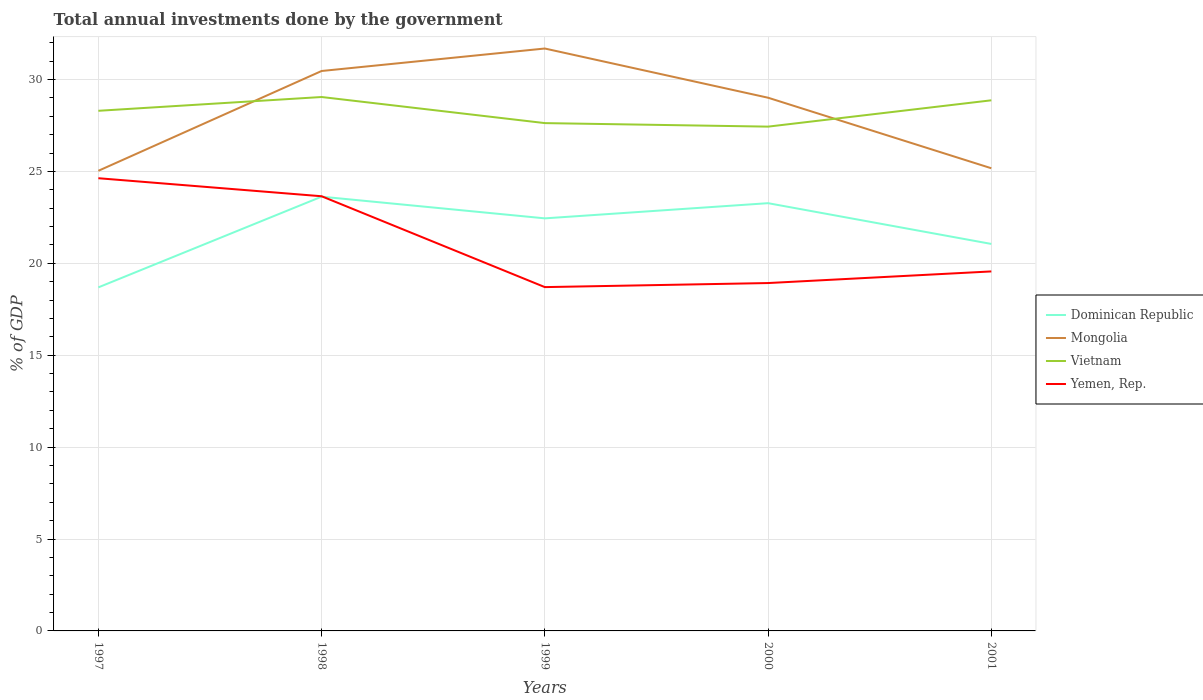Is the number of lines equal to the number of legend labels?
Provide a short and direct response. Yes. Across all years, what is the maximum total annual investments done by the government in Dominican Republic?
Your answer should be compact. 18.69. In which year was the total annual investments done by the government in Mongolia maximum?
Make the answer very short. 1997. What is the total total annual investments done by the government in Dominican Republic in the graph?
Your response must be concise. 1.18. What is the difference between the highest and the second highest total annual investments done by the government in Mongolia?
Your answer should be very brief. 6.65. What is the difference between the highest and the lowest total annual investments done by the government in Yemen, Rep.?
Provide a short and direct response. 2. Is the total annual investments done by the government in Yemen, Rep. strictly greater than the total annual investments done by the government in Dominican Republic over the years?
Offer a very short reply. No. How many years are there in the graph?
Keep it short and to the point. 5. What is the difference between two consecutive major ticks on the Y-axis?
Offer a terse response. 5. Does the graph contain any zero values?
Your answer should be compact. No. How are the legend labels stacked?
Keep it short and to the point. Vertical. What is the title of the graph?
Provide a short and direct response. Total annual investments done by the government. Does "Senegal" appear as one of the legend labels in the graph?
Offer a terse response. No. What is the label or title of the X-axis?
Provide a short and direct response. Years. What is the label or title of the Y-axis?
Provide a succinct answer. % of GDP. What is the % of GDP of Dominican Republic in 1997?
Your response must be concise. 18.69. What is the % of GDP in Mongolia in 1997?
Provide a succinct answer. 25.03. What is the % of GDP of Vietnam in 1997?
Your response must be concise. 28.3. What is the % of GDP of Yemen, Rep. in 1997?
Offer a terse response. 24.63. What is the % of GDP of Dominican Republic in 1998?
Keep it short and to the point. 23.63. What is the % of GDP of Mongolia in 1998?
Keep it short and to the point. 30.47. What is the % of GDP of Vietnam in 1998?
Provide a succinct answer. 29.05. What is the % of GDP in Yemen, Rep. in 1998?
Your answer should be very brief. 23.65. What is the % of GDP of Dominican Republic in 1999?
Make the answer very short. 22.45. What is the % of GDP of Mongolia in 1999?
Make the answer very short. 31.69. What is the % of GDP in Vietnam in 1999?
Ensure brevity in your answer.  27.63. What is the % of GDP of Yemen, Rep. in 1999?
Give a very brief answer. 18.71. What is the % of GDP of Dominican Republic in 2000?
Offer a terse response. 23.27. What is the % of GDP of Mongolia in 2000?
Offer a terse response. 29.01. What is the % of GDP in Vietnam in 2000?
Your response must be concise. 27.44. What is the % of GDP of Yemen, Rep. in 2000?
Keep it short and to the point. 18.93. What is the % of GDP in Dominican Republic in 2001?
Keep it short and to the point. 21.06. What is the % of GDP in Mongolia in 2001?
Provide a succinct answer. 25.17. What is the % of GDP of Vietnam in 2001?
Your response must be concise. 28.87. What is the % of GDP of Yemen, Rep. in 2001?
Keep it short and to the point. 19.56. Across all years, what is the maximum % of GDP of Dominican Republic?
Keep it short and to the point. 23.63. Across all years, what is the maximum % of GDP in Mongolia?
Ensure brevity in your answer.  31.69. Across all years, what is the maximum % of GDP of Vietnam?
Provide a succinct answer. 29.05. Across all years, what is the maximum % of GDP of Yemen, Rep.?
Keep it short and to the point. 24.63. Across all years, what is the minimum % of GDP in Dominican Republic?
Make the answer very short. 18.69. Across all years, what is the minimum % of GDP of Mongolia?
Offer a very short reply. 25.03. Across all years, what is the minimum % of GDP of Vietnam?
Make the answer very short. 27.44. Across all years, what is the minimum % of GDP in Yemen, Rep.?
Provide a short and direct response. 18.71. What is the total % of GDP of Dominican Republic in the graph?
Ensure brevity in your answer.  109.1. What is the total % of GDP of Mongolia in the graph?
Keep it short and to the point. 141.37. What is the total % of GDP of Vietnam in the graph?
Give a very brief answer. 141.29. What is the total % of GDP in Yemen, Rep. in the graph?
Provide a short and direct response. 105.48. What is the difference between the % of GDP in Dominican Republic in 1997 and that in 1998?
Your answer should be compact. -4.93. What is the difference between the % of GDP of Mongolia in 1997 and that in 1998?
Provide a succinct answer. -5.43. What is the difference between the % of GDP in Vietnam in 1997 and that in 1998?
Your response must be concise. -0.75. What is the difference between the % of GDP in Yemen, Rep. in 1997 and that in 1998?
Your answer should be compact. 0.98. What is the difference between the % of GDP of Dominican Republic in 1997 and that in 1999?
Offer a very short reply. -3.76. What is the difference between the % of GDP in Mongolia in 1997 and that in 1999?
Provide a short and direct response. -6.65. What is the difference between the % of GDP of Vietnam in 1997 and that in 1999?
Give a very brief answer. 0.67. What is the difference between the % of GDP of Yemen, Rep. in 1997 and that in 1999?
Offer a terse response. 5.92. What is the difference between the % of GDP of Dominican Republic in 1997 and that in 2000?
Keep it short and to the point. -4.58. What is the difference between the % of GDP in Mongolia in 1997 and that in 2000?
Offer a very short reply. -3.98. What is the difference between the % of GDP of Vietnam in 1997 and that in 2000?
Provide a succinct answer. 0.86. What is the difference between the % of GDP in Yemen, Rep. in 1997 and that in 2000?
Give a very brief answer. 5.7. What is the difference between the % of GDP of Dominican Republic in 1997 and that in 2001?
Your answer should be very brief. -2.36. What is the difference between the % of GDP in Mongolia in 1997 and that in 2001?
Offer a terse response. -0.14. What is the difference between the % of GDP of Vietnam in 1997 and that in 2001?
Give a very brief answer. -0.57. What is the difference between the % of GDP of Yemen, Rep. in 1997 and that in 2001?
Provide a short and direct response. 5.07. What is the difference between the % of GDP of Dominican Republic in 1998 and that in 1999?
Your answer should be compact. 1.18. What is the difference between the % of GDP of Mongolia in 1998 and that in 1999?
Offer a very short reply. -1.22. What is the difference between the % of GDP of Vietnam in 1998 and that in 1999?
Your answer should be very brief. 1.42. What is the difference between the % of GDP of Yemen, Rep. in 1998 and that in 1999?
Your answer should be very brief. 4.94. What is the difference between the % of GDP of Dominican Republic in 1998 and that in 2000?
Ensure brevity in your answer.  0.35. What is the difference between the % of GDP of Mongolia in 1998 and that in 2000?
Offer a terse response. 1.45. What is the difference between the % of GDP of Vietnam in 1998 and that in 2000?
Provide a short and direct response. 1.61. What is the difference between the % of GDP in Yemen, Rep. in 1998 and that in 2000?
Provide a short and direct response. 4.72. What is the difference between the % of GDP in Dominican Republic in 1998 and that in 2001?
Offer a terse response. 2.57. What is the difference between the % of GDP in Mongolia in 1998 and that in 2001?
Make the answer very short. 5.29. What is the difference between the % of GDP in Vietnam in 1998 and that in 2001?
Your answer should be compact. 0.18. What is the difference between the % of GDP in Yemen, Rep. in 1998 and that in 2001?
Provide a short and direct response. 4.09. What is the difference between the % of GDP in Dominican Republic in 1999 and that in 2000?
Offer a very short reply. -0.83. What is the difference between the % of GDP of Mongolia in 1999 and that in 2000?
Keep it short and to the point. 2.68. What is the difference between the % of GDP in Vietnam in 1999 and that in 2000?
Keep it short and to the point. 0.19. What is the difference between the % of GDP of Yemen, Rep. in 1999 and that in 2000?
Ensure brevity in your answer.  -0.22. What is the difference between the % of GDP in Dominican Republic in 1999 and that in 2001?
Give a very brief answer. 1.39. What is the difference between the % of GDP in Mongolia in 1999 and that in 2001?
Your answer should be compact. 6.51. What is the difference between the % of GDP in Vietnam in 1999 and that in 2001?
Offer a terse response. -1.24. What is the difference between the % of GDP in Yemen, Rep. in 1999 and that in 2001?
Make the answer very short. -0.85. What is the difference between the % of GDP in Dominican Republic in 2000 and that in 2001?
Your answer should be compact. 2.22. What is the difference between the % of GDP of Mongolia in 2000 and that in 2001?
Offer a terse response. 3.84. What is the difference between the % of GDP in Vietnam in 2000 and that in 2001?
Provide a short and direct response. -1.43. What is the difference between the % of GDP in Yemen, Rep. in 2000 and that in 2001?
Keep it short and to the point. -0.63. What is the difference between the % of GDP of Dominican Republic in 1997 and the % of GDP of Mongolia in 1998?
Your answer should be very brief. -11.77. What is the difference between the % of GDP in Dominican Republic in 1997 and the % of GDP in Vietnam in 1998?
Give a very brief answer. -10.36. What is the difference between the % of GDP in Dominican Republic in 1997 and the % of GDP in Yemen, Rep. in 1998?
Ensure brevity in your answer.  -4.96. What is the difference between the % of GDP in Mongolia in 1997 and the % of GDP in Vietnam in 1998?
Provide a short and direct response. -4.02. What is the difference between the % of GDP in Mongolia in 1997 and the % of GDP in Yemen, Rep. in 1998?
Offer a terse response. 1.38. What is the difference between the % of GDP of Vietnam in 1997 and the % of GDP of Yemen, Rep. in 1998?
Keep it short and to the point. 4.65. What is the difference between the % of GDP of Dominican Republic in 1997 and the % of GDP of Mongolia in 1999?
Your answer should be very brief. -13. What is the difference between the % of GDP in Dominican Republic in 1997 and the % of GDP in Vietnam in 1999?
Your response must be concise. -8.94. What is the difference between the % of GDP in Dominican Republic in 1997 and the % of GDP in Yemen, Rep. in 1999?
Provide a short and direct response. -0.01. What is the difference between the % of GDP in Mongolia in 1997 and the % of GDP in Vietnam in 1999?
Provide a short and direct response. -2.6. What is the difference between the % of GDP of Mongolia in 1997 and the % of GDP of Yemen, Rep. in 1999?
Your answer should be very brief. 6.33. What is the difference between the % of GDP of Vietnam in 1997 and the % of GDP of Yemen, Rep. in 1999?
Offer a very short reply. 9.59. What is the difference between the % of GDP of Dominican Republic in 1997 and the % of GDP of Mongolia in 2000?
Make the answer very short. -10.32. What is the difference between the % of GDP in Dominican Republic in 1997 and the % of GDP in Vietnam in 2000?
Your answer should be compact. -8.75. What is the difference between the % of GDP of Dominican Republic in 1997 and the % of GDP of Yemen, Rep. in 2000?
Give a very brief answer. -0.24. What is the difference between the % of GDP of Mongolia in 1997 and the % of GDP of Vietnam in 2000?
Your answer should be very brief. -2.4. What is the difference between the % of GDP of Mongolia in 1997 and the % of GDP of Yemen, Rep. in 2000?
Offer a very short reply. 6.11. What is the difference between the % of GDP of Vietnam in 1997 and the % of GDP of Yemen, Rep. in 2000?
Your answer should be compact. 9.37. What is the difference between the % of GDP of Dominican Republic in 1997 and the % of GDP of Mongolia in 2001?
Your answer should be very brief. -6.48. What is the difference between the % of GDP in Dominican Republic in 1997 and the % of GDP in Vietnam in 2001?
Your answer should be very brief. -10.18. What is the difference between the % of GDP in Dominican Republic in 1997 and the % of GDP in Yemen, Rep. in 2001?
Your response must be concise. -0.87. What is the difference between the % of GDP in Mongolia in 1997 and the % of GDP in Vietnam in 2001?
Make the answer very short. -3.84. What is the difference between the % of GDP of Mongolia in 1997 and the % of GDP of Yemen, Rep. in 2001?
Provide a succinct answer. 5.47. What is the difference between the % of GDP in Vietnam in 1997 and the % of GDP in Yemen, Rep. in 2001?
Give a very brief answer. 8.74. What is the difference between the % of GDP of Dominican Republic in 1998 and the % of GDP of Mongolia in 1999?
Offer a terse response. -8.06. What is the difference between the % of GDP in Dominican Republic in 1998 and the % of GDP in Vietnam in 1999?
Give a very brief answer. -4. What is the difference between the % of GDP of Dominican Republic in 1998 and the % of GDP of Yemen, Rep. in 1999?
Provide a succinct answer. 4.92. What is the difference between the % of GDP in Mongolia in 1998 and the % of GDP in Vietnam in 1999?
Offer a terse response. 2.84. What is the difference between the % of GDP of Mongolia in 1998 and the % of GDP of Yemen, Rep. in 1999?
Offer a very short reply. 11.76. What is the difference between the % of GDP of Vietnam in 1998 and the % of GDP of Yemen, Rep. in 1999?
Offer a terse response. 10.34. What is the difference between the % of GDP of Dominican Republic in 1998 and the % of GDP of Mongolia in 2000?
Provide a succinct answer. -5.38. What is the difference between the % of GDP in Dominican Republic in 1998 and the % of GDP in Vietnam in 2000?
Offer a very short reply. -3.81. What is the difference between the % of GDP of Dominican Republic in 1998 and the % of GDP of Yemen, Rep. in 2000?
Ensure brevity in your answer.  4.7. What is the difference between the % of GDP in Mongolia in 1998 and the % of GDP in Vietnam in 2000?
Ensure brevity in your answer.  3.03. What is the difference between the % of GDP of Mongolia in 1998 and the % of GDP of Yemen, Rep. in 2000?
Offer a very short reply. 11.54. What is the difference between the % of GDP of Vietnam in 1998 and the % of GDP of Yemen, Rep. in 2000?
Provide a short and direct response. 10.12. What is the difference between the % of GDP of Dominican Republic in 1998 and the % of GDP of Mongolia in 2001?
Provide a succinct answer. -1.55. What is the difference between the % of GDP in Dominican Republic in 1998 and the % of GDP in Vietnam in 2001?
Make the answer very short. -5.24. What is the difference between the % of GDP of Dominican Republic in 1998 and the % of GDP of Yemen, Rep. in 2001?
Provide a short and direct response. 4.07. What is the difference between the % of GDP in Mongolia in 1998 and the % of GDP in Vietnam in 2001?
Keep it short and to the point. 1.59. What is the difference between the % of GDP of Mongolia in 1998 and the % of GDP of Yemen, Rep. in 2001?
Provide a succinct answer. 10.91. What is the difference between the % of GDP of Vietnam in 1998 and the % of GDP of Yemen, Rep. in 2001?
Make the answer very short. 9.49. What is the difference between the % of GDP in Dominican Republic in 1999 and the % of GDP in Mongolia in 2000?
Make the answer very short. -6.56. What is the difference between the % of GDP of Dominican Republic in 1999 and the % of GDP of Vietnam in 2000?
Offer a terse response. -4.99. What is the difference between the % of GDP of Dominican Republic in 1999 and the % of GDP of Yemen, Rep. in 2000?
Ensure brevity in your answer.  3.52. What is the difference between the % of GDP of Mongolia in 1999 and the % of GDP of Vietnam in 2000?
Ensure brevity in your answer.  4.25. What is the difference between the % of GDP of Mongolia in 1999 and the % of GDP of Yemen, Rep. in 2000?
Make the answer very short. 12.76. What is the difference between the % of GDP in Vietnam in 1999 and the % of GDP in Yemen, Rep. in 2000?
Ensure brevity in your answer.  8.7. What is the difference between the % of GDP of Dominican Republic in 1999 and the % of GDP of Mongolia in 2001?
Keep it short and to the point. -2.73. What is the difference between the % of GDP in Dominican Republic in 1999 and the % of GDP in Vietnam in 2001?
Make the answer very short. -6.42. What is the difference between the % of GDP in Dominican Republic in 1999 and the % of GDP in Yemen, Rep. in 2001?
Your answer should be compact. 2.89. What is the difference between the % of GDP of Mongolia in 1999 and the % of GDP of Vietnam in 2001?
Keep it short and to the point. 2.82. What is the difference between the % of GDP in Mongolia in 1999 and the % of GDP in Yemen, Rep. in 2001?
Offer a very short reply. 12.13. What is the difference between the % of GDP in Vietnam in 1999 and the % of GDP in Yemen, Rep. in 2001?
Give a very brief answer. 8.07. What is the difference between the % of GDP of Dominican Republic in 2000 and the % of GDP of Mongolia in 2001?
Give a very brief answer. -1.9. What is the difference between the % of GDP of Dominican Republic in 2000 and the % of GDP of Vietnam in 2001?
Make the answer very short. -5.6. What is the difference between the % of GDP in Dominican Republic in 2000 and the % of GDP in Yemen, Rep. in 2001?
Provide a succinct answer. 3.71. What is the difference between the % of GDP of Mongolia in 2000 and the % of GDP of Vietnam in 2001?
Keep it short and to the point. 0.14. What is the difference between the % of GDP of Mongolia in 2000 and the % of GDP of Yemen, Rep. in 2001?
Provide a short and direct response. 9.45. What is the difference between the % of GDP of Vietnam in 2000 and the % of GDP of Yemen, Rep. in 2001?
Offer a terse response. 7.88. What is the average % of GDP in Dominican Republic per year?
Make the answer very short. 21.82. What is the average % of GDP of Mongolia per year?
Keep it short and to the point. 28.27. What is the average % of GDP of Vietnam per year?
Give a very brief answer. 28.26. What is the average % of GDP in Yemen, Rep. per year?
Your answer should be very brief. 21.1. In the year 1997, what is the difference between the % of GDP of Dominican Republic and % of GDP of Mongolia?
Make the answer very short. -6.34. In the year 1997, what is the difference between the % of GDP of Dominican Republic and % of GDP of Vietnam?
Your response must be concise. -9.61. In the year 1997, what is the difference between the % of GDP in Dominican Republic and % of GDP in Yemen, Rep.?
Your response must be concise. -5.94. In the year 1997, what is the difference between the % of GDP of Mongolia and % of GDP of Vietnam?
Your response must be concise. -3.26. In the year 1997, what is the difference between the % of GDP of Mongolia and % of GDP of Yemen, Rep.?
Make the answer very short. 0.4. In the year 1997, what is the difference between the % of GDP of Vietnam and % of GDP of Yemen, Rep.?
Give a very brief answer. 3.67. In the year 1998, what is the difference between the % of GDP in Dominican Republic and % of GDP in Mongolia?
Make the answer very short. -6.84. In the year 1998, what is the difference between the % of GDP in Dominican Republic and % of GDP in Vietnam?
Offer a terse response. -5.42. In the year 1998, what is the difference between the % of GDP in Dominican Republic and % of GDP in Yemen, Rep.?
Give a very brief answer. -0.02. In the year 1998, what is the difference between the % of GDP of Mongolia and % of GDP of Vietnam?
Your answer should be very brief. 1.42. In the year 1998, what is the difference between the % of GDP in Mongolia and % of GDP in Yemen, Rep.?
Your answer should be very brief. 6.82. In the year 1998, what is the difference between the % of GDP of Vietnam and % of GDP of Yemen, Rep.?
Provide a succinct answer. 5.4. In the year 1999, what is the difference between the % of GDP of Dominican Republic and % of GDP of Mongolia?
Your response must be concise. -9.24. In the year 1999, what is the difference between the % of GDP of Dominican Republic and % of GDP of Vietnam?
Provide a short and direct response. -5.18. In the year 1999, what is the difference between the % of GDP of Dominican Republic and % of GDP of Yemen, Rep.?
Provide a succinct answer. 3.74. In the year 1999, what is the difference between the % of GDP of Mongolia and % of GDP of Vietnam?
Your response must be concise. 4.06. In the year 1999, what is the difference between the % of GDP in Mongolia and % of GDP in Yemen, Rep.?
Your response must be concise. 12.98. In the year 1999, what is the difference between the % of GDP in Vietnam and % of GDP in Yemen, Rep.?
Provide a short and direct response. 8.92. In the year 2000, what is the difference between the % of GDP in Dominican Republic and % of GDP in Mongolia?
Your answer should be compact. -5.74. In the year 2000, what is the difference between the % of GDP of Dominican Republic and % of GDP of Vietnam?
Ensure brevity in your answer.  -4.16. In the year 2000, what is the difference between the % of GDP in Dominican Republic and % of GDP in Yemen, Rep.?
Provide a short and direct response. 4.35. In the year 2000, what is the difference between the % of GDP of Mongolia and % of GDP of Vietnam?
Your answer should be very brief. 1.57. In the year 2000, what is the difference between the % of GDP of Mongolia and % of GDP of Yemen, Rep.?
Provide a succinct answer. 10.08. In the year 2000, what is the difference between the % of GDP in Vietnam and % of GDP in Yemen, Rep.?
Offer a terse response. 8.51. In the year 2001, what is the difference between the % of GDP in Dominican Republic and % of GDP in Mongolia?
Your answer should be compact. -4.12. In the year 2001, what is the difference between the % of GDP in Dominican Republic and % of GDP in Vietnam?
Your answer should be compact. -7.82. In the year 2001, what is the difference between the % of GDP in Dominican Republic and % of GDP in Yemen, Rep.?
Provide a short and direct response. 1.49. In the year 2001, what is the difference between the % of GDP of Mongolia and % of GDP of Vietnam?
Offer a terse response. -3.7. In the year 2001, what is the difference between the % of GDP of Mongolia and % of GDP of Yemen, Rep.?
Make the answer very short. 5.61. In the year 2001, what is the difference between the % of GDP in Vietnam and % of GDP in Yemen, Rep.?
Provide a succinct answer. 9.31. What is the ratio of the % of GDP of Dominican Republic in 1997 to that in 1998?
Keep it short and to the point. 0.79. What is the ratio of the % of GDP in Mongolia in 1997 to that in 1998?
Your answer should be compact. 0.82. What is the ratio of the % of GDP of Vietnam in 1997 to that in 1998?
Your response must be concise. 0.97. What is the ratio of the % of GDP of Yemen, Rep. in 1997 to that in 1998?
Give a very brief answer. 1.04. What is the ratio of the % of GDP of Dominican Republic in 1997 to that in 1999?
Offer a terse response. 0.83. What is the ratio of the % of GDP in Mongolia in 1997 to that in 1999?
Offer a terse response. 0.79. What is the ratio of the % of GDP of Vietnam in 1997 to that in 1999?
Ensure brevity in your answer.  1.02. What is the ratio of the % of GDP of Yemen, Rep. in 1997 to that in 1999?
Your response must be concise. 1.32. What is the ratio of the % of GDP of Dominican Republic in 1997 to that in 2000?
Provide a short and direct response. 0.8. What is the ratio of the % of GDP in Mongolia in 1997 to that in 2000?
Provide a short and direct response. 0.86. What is the ratio of the % of GDP of Vietnam in 1997 to that in 2000?
Offer a terse response. 1.03. What is the ratio of the % of GDP in Yemen, Rep. in 1997 to that in 2000?
Offer a terse response. 1.3. What is the ratio of the % of GDP in Dominican Republic in 1997 to that in 2001?
Provide a succinct answer. 0.89. What is the ratio of the % of GDP in Mongolia in 1997 to that in 2001?
Offer a terse response. 0.99. What is the ratio of the % of GDP in Vietnam in 1997 to that in 2001?
Ensure brevity in your answer.  0.98. What is the ratio of the % of GDP in Yemen, Rep. in 1997 to that in 2001?
Your response must be concise. 1.26. What is the ratio of the % of GDP in Dominican Republic in 1998 to that in 1999?
Your response must be concise. 1.05. What is the ratio of the % of GDP of Mongolia in 1998 to that in 1999?
Provide a short and direct response. 0.96. What is the ratio of the % of GDP of Vietnam in 1998 to that in 1999?
Make the answer very short. 1.05. What is the ratio of the % of GDP of Yemen, Rep. in 1998 to that in 1999?
Offer a terse response. 1.26. What is the ratio of the % of GDP of Dominican Republic in 1998 to that in 2000?
Your answer should be very brief. 1.02. What is the ratio of the % of GDP of Mongolia in 1998 to that in 2000?
Make the answer very short. 1.05. What is the ratio of the % of GDP of Vietnam in 1998 to that in 2000?
Your answer should be compact. 1.06. What is the ratio of the % of GDP in Yemen, Rep. in 1998 to that in 2000?
Keep it short and to the point. 1.25. What is the ratio of the % of GDP of Dominican Republic in 1998 to that in 2001?
Your answer should be compact. 1.12. What is the ratio of the % of GDP of Mongolia in 1998 to that in 2001?
Make the answer very short. 1.21. What is the ratio of the % of GDP of Vietnam in 1998 to that in 2001?
Provide a short and direct response. 1.01. What is the ratio of the % of GDP in Yemen, Rep. in 1998 to that in 2001?
Your response must be concise. 1.21. What is the ratio of the % of GDP in Dominican Republic in 1999 to that in 2000?
Provide a succinct answer. 0.96. What is the ratio of the % of GDP of Mongolia in 1999 to that in 2000?
Provide a short and direct response. 1.09. What is the ratio of the % of GDP of Yemen, Rep. in 1999 to that in 2000?
Ensure brevity in your answer.  0.99. What is the ratio of the % of GDP of Dominican Republic in 1999 to that in 2001?
Provide a succinct answer. 1.07. What is the ratio of the % of GDP in Mongolia in 1999 to that in 2001?
Your answer should be very brief. 1.26. What is the ratio of the % of GDP of Yemen, Rep. in 1999 to that in 2001?
Ensure brevity in your answer.  0.96. What is the ratio of the % of GDP of Dominican Republic in 2000 to that in 2001?
Your answer should be compact. 1.11. What is the ratio of the % of GDP in Mongolia in 2000 to that in 2001?
Offer a terse response. 1.15. What is the ratio of the % of GDP in Vietnam in 2000 to that in 2001?
Offer a terse response. 0.95. What is the difference between the highest and the second highest % of GDP of Dominican Republic?
Offer a terse response. 0.35. What is the difference between the highest and the second highest % of GDP in Mongolia?
Give a very brief answer. 1.22. What is the difference between the highest and the second highest % of GDP in Vietnam?
Offer a terse response. 0.18. What is the difference between the highest and the second highest % of GDP in Yemen, Rep.?
Offer a terse response. 0.98. What is the difference between the highest and the lowest % of GDP in Dominican Republic?
Give a very brief answer. 4.93. What is the difference between the highest and the lowest % of GDP in Mongolia?
Provide a succinct answer. 6.65. What is the difference between the highest and the lowest % of GDP of Vietnam?
Give a very brief answer. 1.61. What is the difference between the highest and the lowest % of GDP in Yemen, Rep.?
Offer a very short reply. 5.92. 